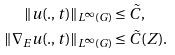Convert formula to latex. <formula><loc_0><loc_0><loc_500><loc_500>\| u ( . , t ) \| _ { L ^ { \infty } ( G ) } & \leq \tilde { C } , \\ \| \nabla _ { E } u ( . , t ) \| _ { L ^ { \infty } ( G ) } & \leq \tilde { C } ( Z ) .</formula> 